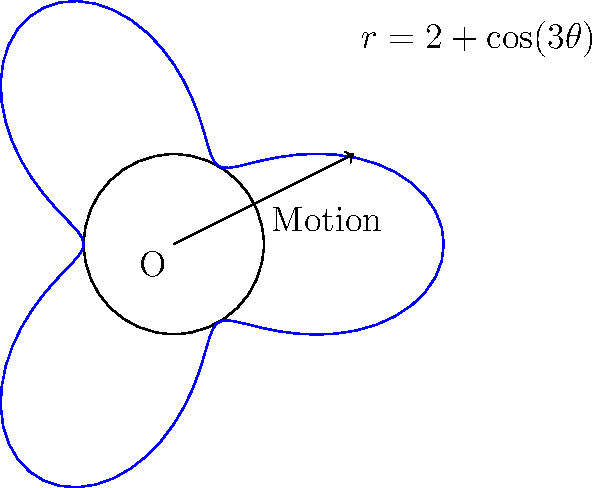A longboard wheel's motion can be described by the polar equation $r = 2 + \cos(3\theta)$, where $r$ is in inches. If the longboard travels one complete revolution, what is the total distance covered by a point on the edge of the wheel? To solve this problem, we need to follow these steps:

1) The total distance covered by a point on the edge of the wheel is equal to the arc length of the polar curve for one complete revolution.

2) The formula for arc length in polar coordinates is:

   $$L = \int_0^{2\pi} \sqrt{r^2 + \left(\frac{dr}{d\theta}\right)^2} d\theta$$

3) We need to find $\frac{dr}{d\theta}$:
   
   $$\frac{dr}{d\theta} = -3\sin(3\theta)$$

4) Now we can set up the integral:

   $$L = \int_0^{2\pi} \sqrt{(2 + \cos(3\theta))^2 + (-3\sin(3\theta))^2} d\theta$$

5) This integral is quite complex and doesn't have a simple analytical solution. In practice, we would use numerical integration methods to evaluate it.

6) Using a numerical integration tool, we find that the value of this integral is approximately 14.38 inches.

This result represents the total distance traveled by a point on the edge of the wheel during one complete revolution of the longboard.
Answer: Approximately 14.38 inches 